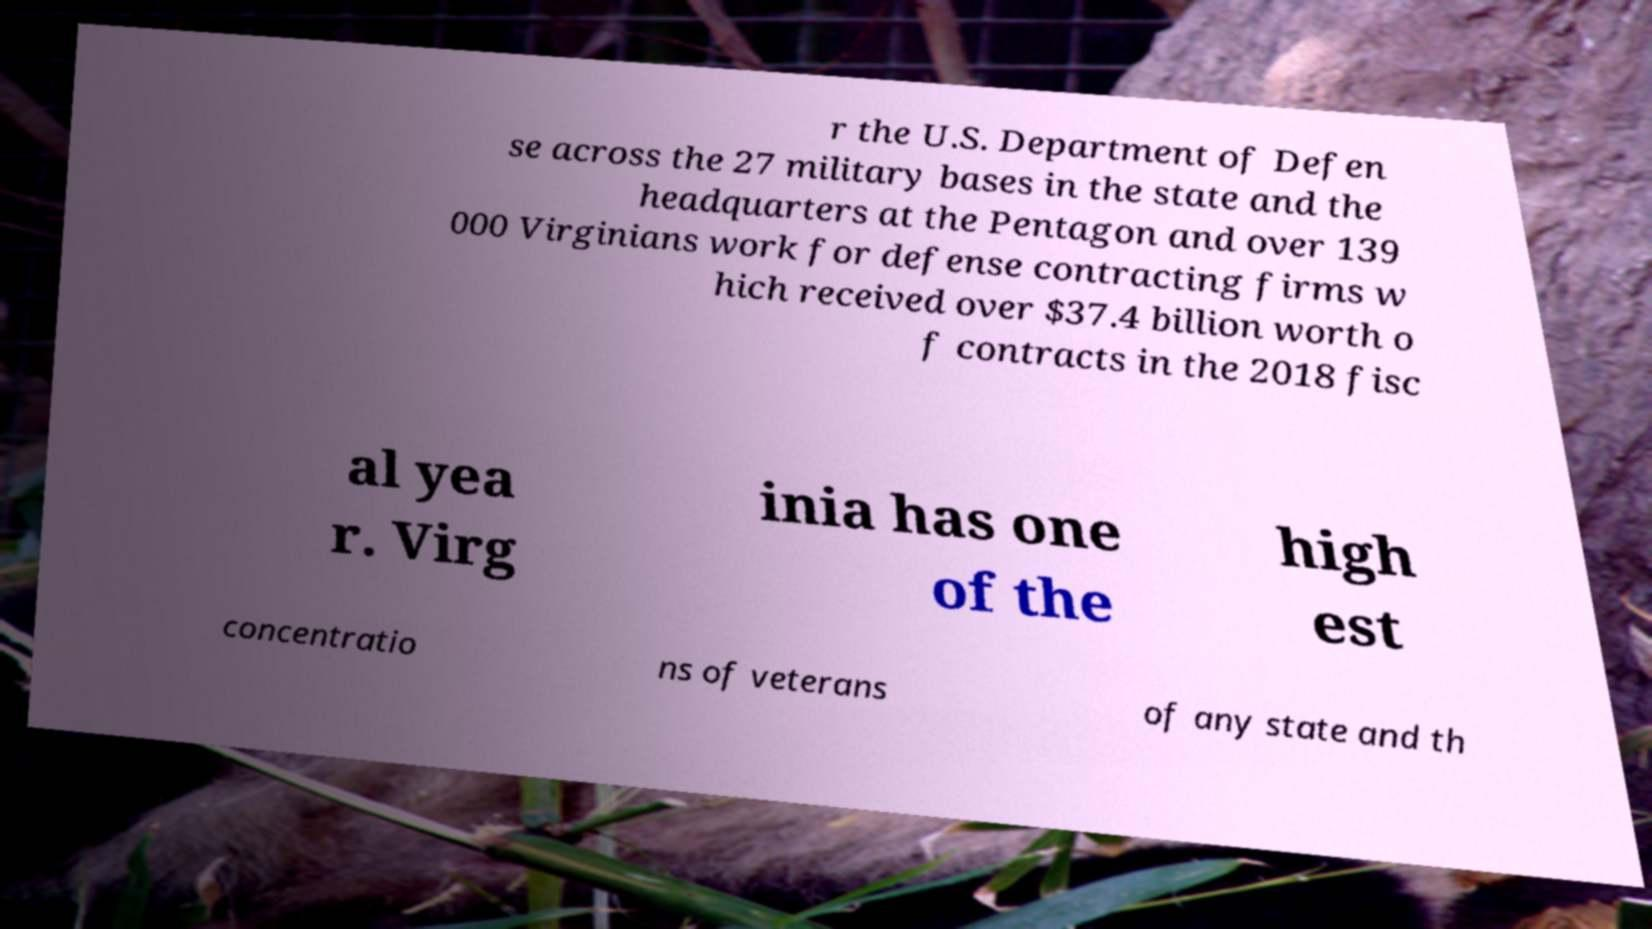I need the written content from this picture converted into text. Can you do that? r the U.S. Department of Defen se across the 27 military bases in the state and the headquarters at the Pentagon and over 139 000 Virginians work for defense contracting firms w hich received over $37.4 billion worth o f contracts in the 2018 fisc al yea r. Virg inia has one of the high est concentratio ns of veterans of any state and th 